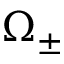Convert formula to latex. <formula><loc_0><loc_0><loc_500><loc_500>\Omega _ { \pm }</formula> 